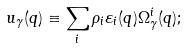Convert formula to latex. <formula><loc_0><loc_0><loc_500><loc_500>u _ { \gamma } ( { q } ) \equiv \sum _ { i } \rho _ { i } \varepsilon _ { i } ( { q } ) \Omega ^ { i } _ { \gamma } ( { q } ) ;</formula> 